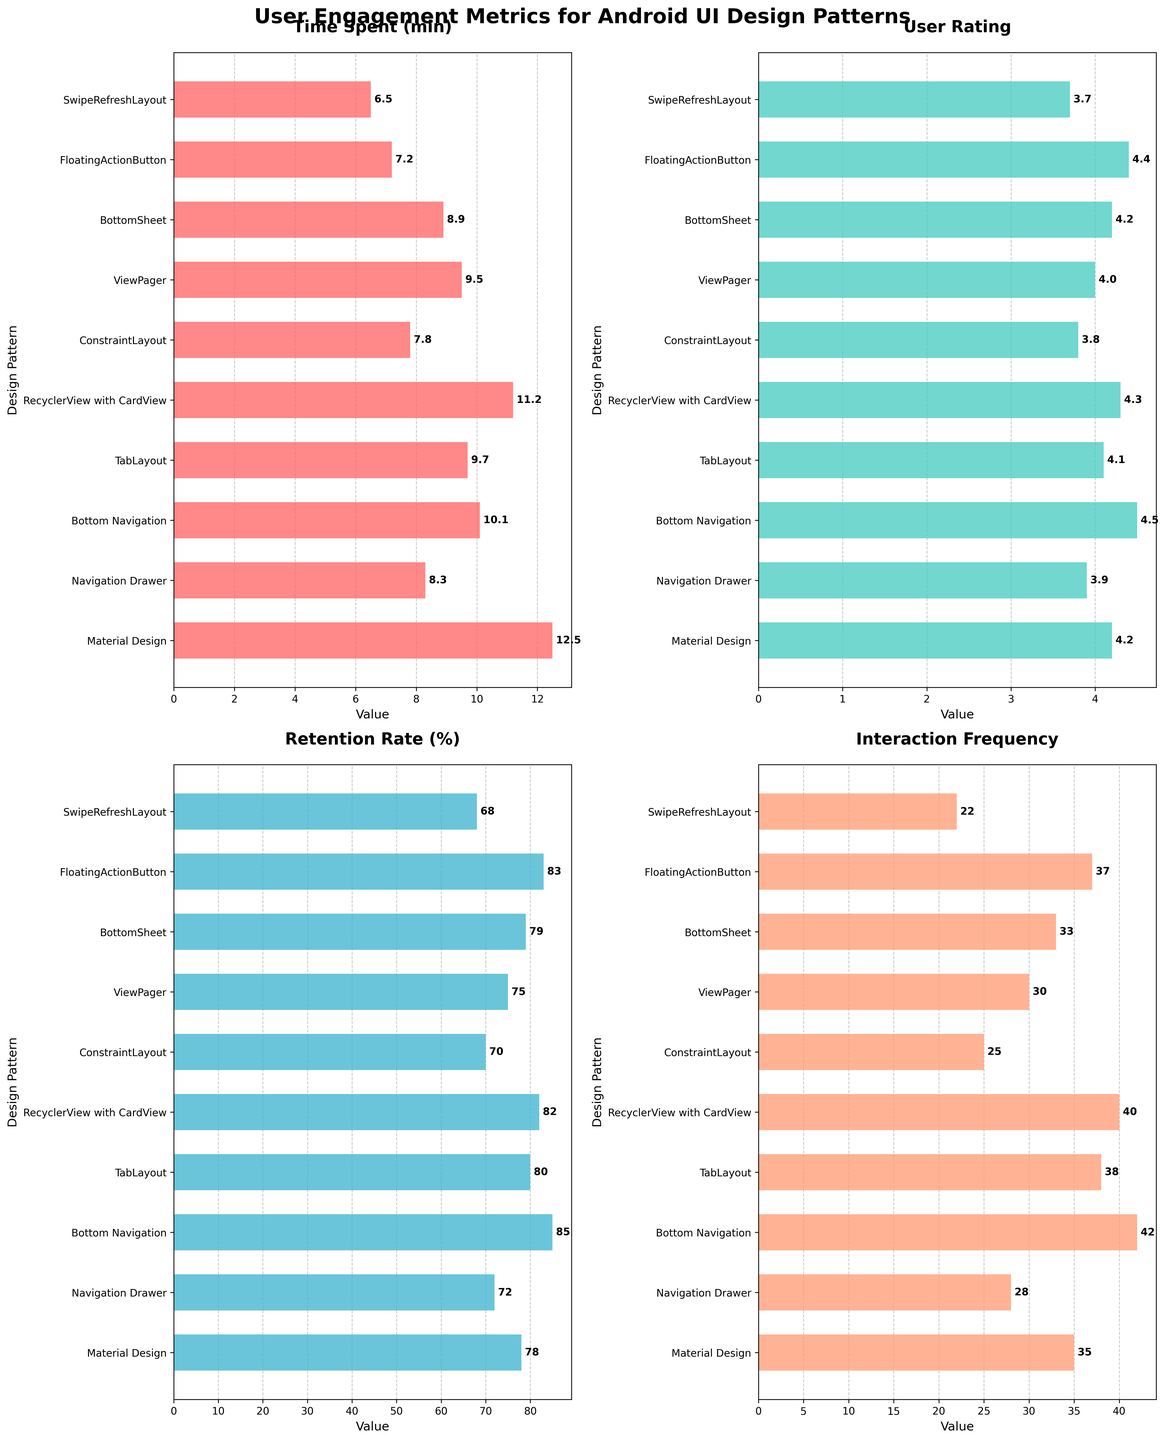What's the title of the entire figure? The title is usually displayed at the top of the figure. In this case, it indicates the overall subject of the multiple subplots, which are covering various user engagement metrics for different UI design patterns in Android apps.
Answer: User Engagement Metrics for Android UI Design Patterns Which design pattern has the highest user rating? To determine the highest user rating, look at the subplot titled "User Rating" and identify the bar that extends the furthest to the right.
Answer: Bottom Navigation How many design patterns are evaluated in total in this figure? Count the number of bars in any subplot (since all subplots have bars corresponding to each design pattern). Each bar corresponds to one design pattern.
Answer: 10 What is the difference in retention rate between Material Design and ConstraintLayout? Locate the "Retention Rate (%)" subplot. Check the bars for Material Design and ConstraintLayout, then subtract the value of ConstraintLayout from that of Material Design.
Answer: 8% Which design pattern has the lowest interaction frequency? In the subplot labeled "Interaction Frequency," identify the bar that has the smallest value (the shortest bar length).
Answer: SwipeRefreshLayout How many design patterns have a user rating above 4.0? In the "User Rating" subplot, count the number of bars whose values exceed the 4.0 mark.
Answer: 7 Among Material Design, Navigation Drawer, and Bottom Navigation, which design pattern leads in time spent? Check the "Time Spent (min)" subplot and compare the bars for Material Design, Navigation Drawer, and Bottom Navigation. Identify the pattern with the highest value.
Answer: Material Design What is the average user rating of all the design patterns combined? Sum the user ratings for all design patterns and divide by the number of design patterns (10). (4.2 + 3.9 + 4.5 + 4.1 + 4.3 + 3.8 + 4.0 + 4.2 + 4.4 + 3.7) / 10 = 4.11
Answer: 4.11 Which design pattern shows the smallest value in "Time Spent (min)" and what is that value? Look at the "Time Spent (min)" subplot and identify the shortest bar, noting down its value.
Answer: SwipeRefreshLayout, 6.5 Compare the interaction frequency of TabLayout and FloatingActionButton. Which one is higher and by how much? In the "Interaction Frequency" subplot, find the bars for TabLayout and FloatingActionButton. Subtract the value of TabLayout from FloatingActionButton's frequency.
Answer: FloatingActionButton, 1 more 